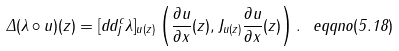<formula> <loc_0><loc_0><loc_500><loc_500>\Delta ( \lambda \circ u ) ( z ) = [ d d ^ { c } _ { J } \lambda ] _ { u ( z ) } \left ( \frac { \partial u } { \partial x } ( z ) , J _ { u ( z ) } \frac { \partial u } { \partial x } ( z ) \right ) . \ e q q n o ( 5 . 1 8 )</formula> 